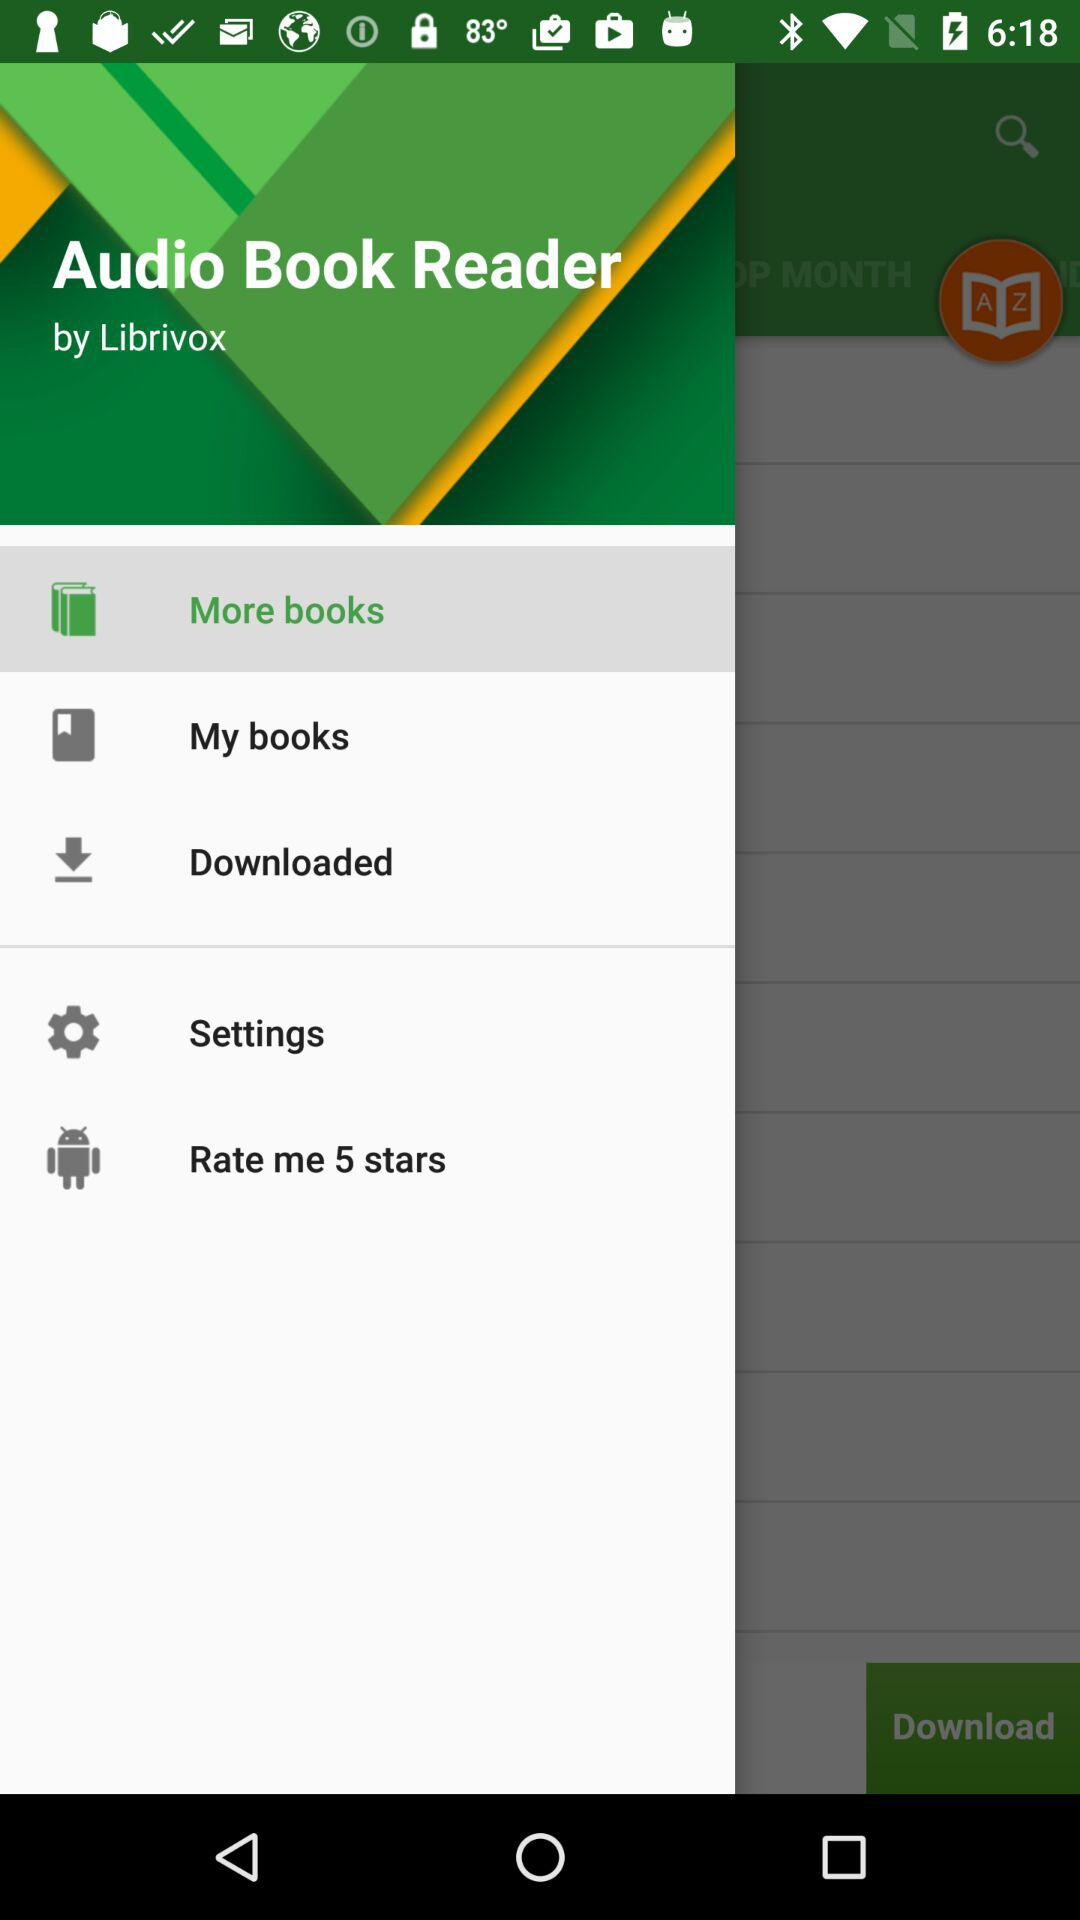Who developed the application? The application was developed by "Librivox". 